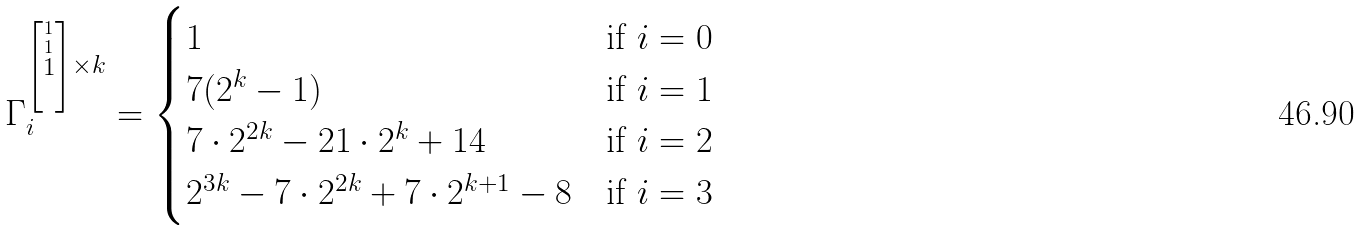<formula> <loc_0><loc_0><loc_500><loc_500>\Gamma _ { i } ^ { \left [ \stackrel { 1 } { \stackrel { 1 } { 1 } } \right ] \times k } = \begin{cases} 1 & \text {if } i = 0 \\ 7 ( 2 ^ { k } - 1 ) & \text {if } i = 1 \\ 7 \cdot 2 ^ { 2 k } - 2 1 \cdot 2 ^ { k } + 1 4 & \text {if  } i = 2 \\ 2 ^ { 3 k } - 7 \cdot 2 ^ { 2 k } + 7 \cdot 2 ^ { k + 1 } - 8 & \text {if  } i = 3 \end{cases}</formula> 